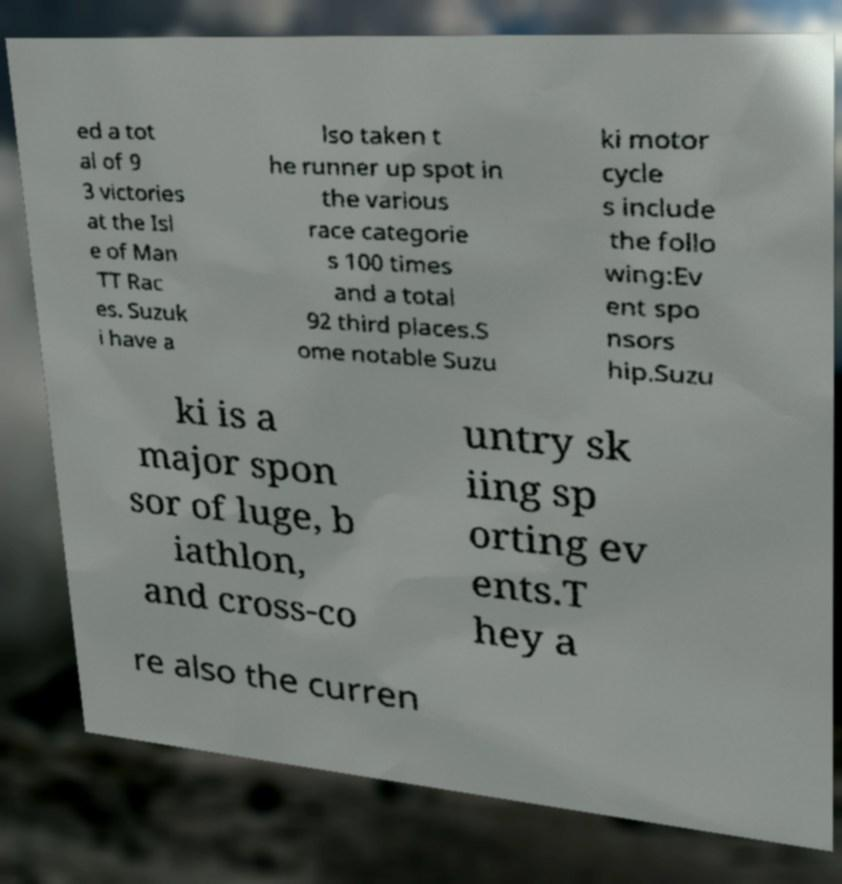Could you extract and type out the text from this image? ed a tot al of 9 3 victories at the Isl e of Man TT Rac es. Suzuk i have a lso taken t he runner up spot in the various race categorie s 100 times and a total 92 third places.S ome notable Suzu ki motor cycle s include the follo wing:Ev ent spo nsors hip.Suzu ki is a major spon sor of luge, b iathlon, and cross-co untry sk iing sp orting ev ents.T hey a re also the curren 